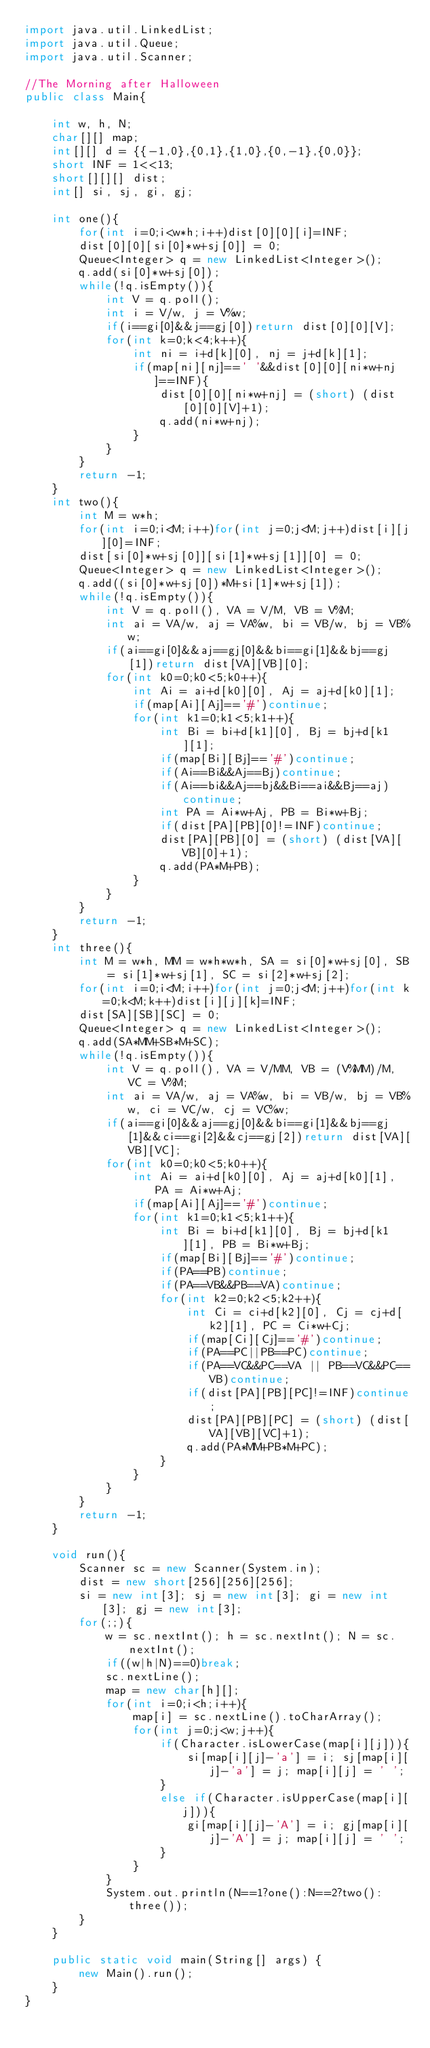Convert code to text. <code><loc_0><loc_0><loc_500><loc_500><_Java_>import java.util.LinkedList;
import java.util.Queue;
import java.util.Scanner;

//The Morning after Halloween
public class Main{

	int w, h, N;
	char[][] map;
	int[][] d = {{-1,0},{0,1},{1,0},{0,-1},{0,0}};
	short INF = 1<<13;
	short[][][] dist;
	int[] si, sj, gi, gj;
	
	int one(){
		for(int i=0;i<w*h;i++)dist[0][0][i]=INF;
		dist[0][0][si[0]*w+sj[0]] = 0;
		Queue<Integer> q = new LinkedList<Integer>();
		q.add(si[0]*w+sj[0]);
		while(!q.isEmpty()){
			int V = q.poll();
			int i = V/w, j = V%w;
			if(i==gi[0]&&j==gj[0])return dist[0][0][V];
			for(int k=0;k<4;k++){
				int ni = i+d[k][0], nj = j+d[k][1];
				if(map[ni][nj]==' '&&dist[0][0][ni*w+nj]==INF){
					dist[0][0][ni*w+nj] = (short) (dist[0][0][V]+1);
					q.add(ni*w+nj);
				}
			}
		}
		return -1;
	}
	int two(){
		int M = w*h;
		for(int i=0;i<M;i++)for(int j=0;j<M;j++)dist[i][j][0]=INF;
		dist[si[0]*w+sj[0]][si[1]*w+sj[1]][0] = 0;
		Queue<Integer> q = new LinkedList<Integer>();
		q.add((si[0]*w+sj[0])*M+si[1]*w+sj[1]);
		while(!q.isEmpty()){
			int V = q.poll(), VA = V/M, VB = V%M;
			int ai = VA/w, aj = VA%w, bi = VB/w, bj = VB%w;
			if(ai==gi[0]&&aj==gj[0]&&bi==gi[1]&&bj==gj[1])return dist[VA][VB][0];
			for(int k0=0;k0<5;k0++){
				int Ai = ai+d[k0][0], Aj = aj+d[k0][1];
				if(map[Ai][Aj]=='#')continue;
				for(int k1=0;k1<5;k1++){
					int Bi = bi+d[k1][0], Bj = bj+d[k1][1];
					if(map[Bi][Bj]=='#')continue;
					if(Ai==Bi&&Aj==Bj)continue;
					if(Ai==bi&&Aj==bj&&Bi==ai&&Bj==aj)continue;
					int PA = Ai*w+Aj, PB = Bi*w+Bj;
					if(dist[PA][PB][0]!=INF)continue;
					dist[PA][PB][0] = (short) (dist[VA][VB][0]+1);
					q.add(PA*M+PB);
				}
			}
		}
		return -1;
	}
	int three(){
		int M = w*h, MM = w*h*w*h, SA = si[0]*w+sj[0], SB = si[1]*w+sj[1], SC = si[2]*w+sj[2];
		for(int i=0;i<M;i++)for(int j=0;j<M;j++)for(int k=0;k<M;k++)dist[i][j][k]=INF;
		dist[SA][SB][SC] = 0;
		Queue<Integer> q = new LinkedList<Integer>();
		q.add(SA*MM+SB*M+SC);
		while(!q.isEmpty()){
			int V = q.poll(), VA = V/MM, VB = (V%MM)/M, VC = V%M;
			int ai = VA/w, aj = VA%w, bi = VB/w, bj = VB%w, ci = VC/w, cj = VC%w;
			if(ai==gi[0]&&aj==gj[0]&&bi==gi[1]&&bj==gj[1]&&ci==gi[2]&&cj==gj[2])return dist[VA][VB][VC];
			for(int k0=0;k0<5;k0++){
				int Ai = ai+d[k0][0], Aj = aj+d[k0][1], PA = Ai*w+Aj;
				if(map[Ai][Aj]=='#')continue;
				for(int k1=0;k1<5;k1++){
					int Bi = bi+d[k1][0], Bj = bj+d[k1][1], PB = Bi*w+Bj;
					if(map[Bi][Bj]=='#')continue;
					if(PA==PB)continue;
					if(PA==VB&&PB==VA)continue;
					for(int k2=0;k2<5;k2++){
						int Ci = ci+d[k2][0], Cj = cj+d[k2][1], PC = Ci*w+Cj;
						if(map[Ci][Cj]=='#')continue;
						if(PA==PC||PB==PC)continue;
						if(PA==VC&&PC==VA || PB==VC&&PC==VB)continue;
						if(dist[PA][PB][PC]!=INF)continue;
						dist[PA][PB][PC] = (short) (dist[VA][VB][VC]+1);
						q.add(PA*MM+PB*M+PC);
					}
				}
			}
		}
		return -1;
	}
	
	void run(){
		Scanner sc = new Scanner(System.in);
		dist = new short[256][256][256];
		si = new int[3]; sj = new int[3]; gi = new int[3]; gj = new int[3];
		for(;;){
			w = sc.nextInt(); h = sc.nextInt(); N = sc.nextInt();
			if((w|h|N)==0)break;
			sc.nextLine();
			map = new char[h][];
			for(int i=0;i<h;i++){
				map[i] = sc.nextLine().toCharArray();
				for(int j=0;j<w;j++){
					if(Character.isLowerCase(map[i][j])){
						si[map[i][j]-'a'] = i; sj[map[i][j]-'a'] = j; map[i][j] = ' ';
					}
					else if(Character.isUpperCase(map[i][j])){
						gi[map[i][j]-'A'] = i; gj[map[i][j]-'A'] = j; map[i][j] = ' ';
					}
				}
			}
			System.out.println(N==1?one():N==2?two():three());
		}
	}
	
	public static void main(String[] args) {
		new Main().run();
	}
}</code> 